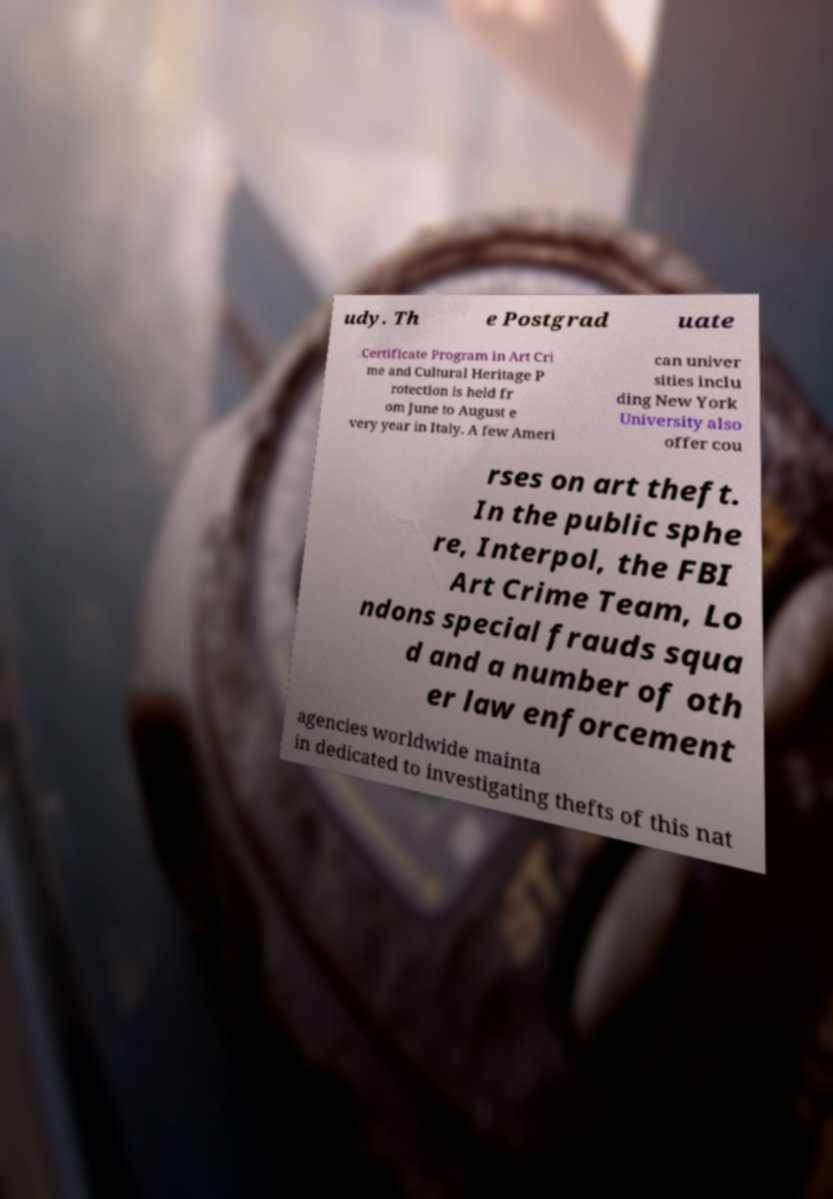Could you assist in decoding the text presented in this image and type it out clearly? udy. Th e Postgrad uate Certificate Program in Art Cri me and Cultural Heritage P rotection is held fr om June to August e very year in Italy. A few Ameri can univer sities inclu ding New York University also offer cou rses on art theft. In the public sphe re, Interpol, the FBI Art Crime Team, Lo ndons special frauds squa d and a number of oth er law enforcement agencies worldwide mainta in dedicated to investigating thefts of this nat 